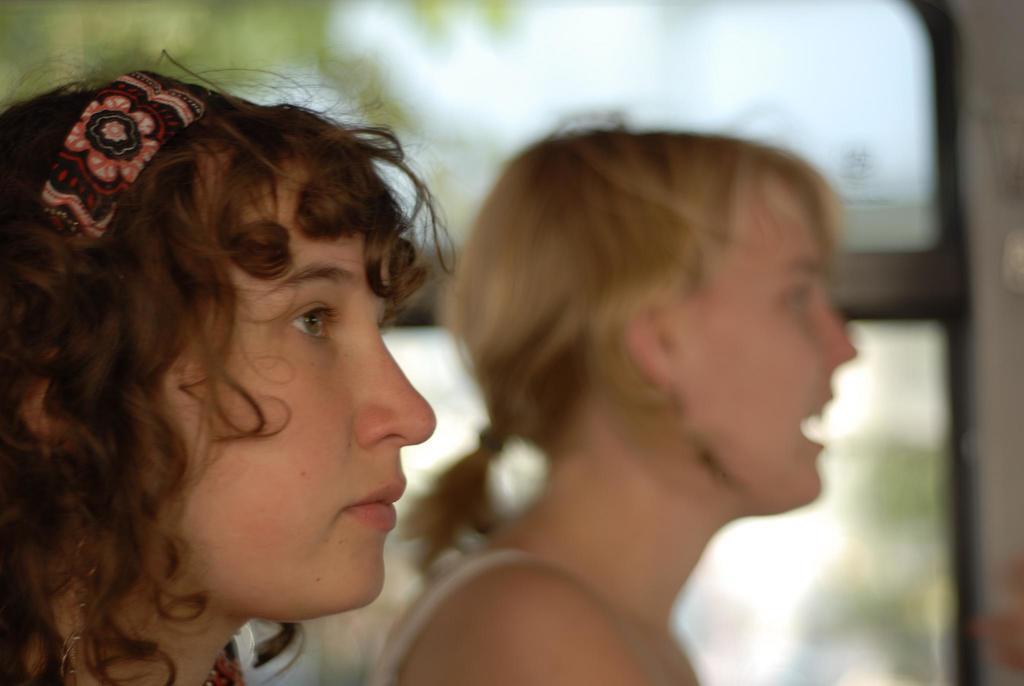Could you give a brief overview of what you see in this image? In this image there is one women at left side is wearing a headband and there is one more women is at middle of this image. 